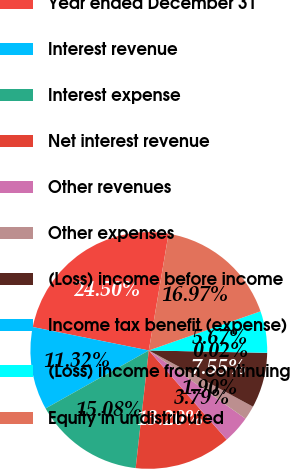<chart> <loc_0><loc_0><loc_500><loc_500><pie_chart><fcel>Year ended December 31<fcel>Interest revenue<fcel>Interest expense<fcel>Net interest revenue<fcel>Other revenues<fcel>Other expenses<fcel>(Loss) income before income<fcel>Income tax benefit (expense)<fcel>(Loss) income from continuing<fcel>Equity in undistributed<nl><fcel>24.5%<fcel>11.32%<fcel>15.08%<fcel>13.2%<fcel>3.79%<fcel>1.9%<fcel>7.55%<fcel>0.02%<fcel>5.67%<fcel>16.97%<nl></chart> 